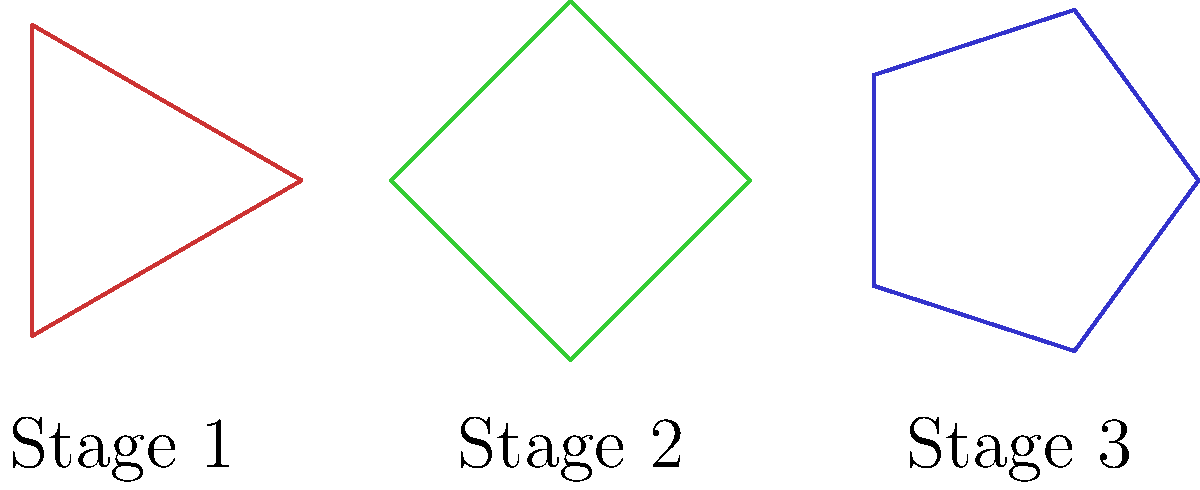In the context of developing regulations for algorithmic decision-making, the diagram represents different stages of policy implementation. What does the progression from left to right most likely symbolize in terms of policy development? To answer this question, let's analyze the diagram step-by-step:

1. We see three shapes: a triangle (Stage 1), a square (Stage 2), and a pentagon (Stage 3).

2. The progression from left to right shows an increase in the number of sides:
   - Stage 1 (triangle): 3 sides
   - Stage 2 (square): 4 sides
   - Stage 3 (pentagon): 5 sides

3. In the context of policy development for algorithmic decision-making:
   - More sides can represent increased complexity or comprehensiveness.
   - The progression suggests a policy that becomes more refined and detailed over time.

4. Considering the persona of a government official responsible for developing regulations:
   - Stage 1 (triangle) might represent initial, basic guidelines with minimal complexity.
   - Stage 2 (square) could indicate a more structured and defined set of regulations.
   - Stage 3 (pentagon) likely represents a comprehensive and nuanced policy framework.

5. This progression aligns with typical policy development processes:
   - Starting with broad principles
   - Moving to more detailed regulations
   - Ending with a complex, multi-faceted policy that addresses various aspects of algorithmic decision-making

Therefore, the progression most likely symbolizes increasing complexity and comprehensiveness in policy development for algorithmic decision-making regulations.
Answer: Increasing policy complexity and comprehensiveness 